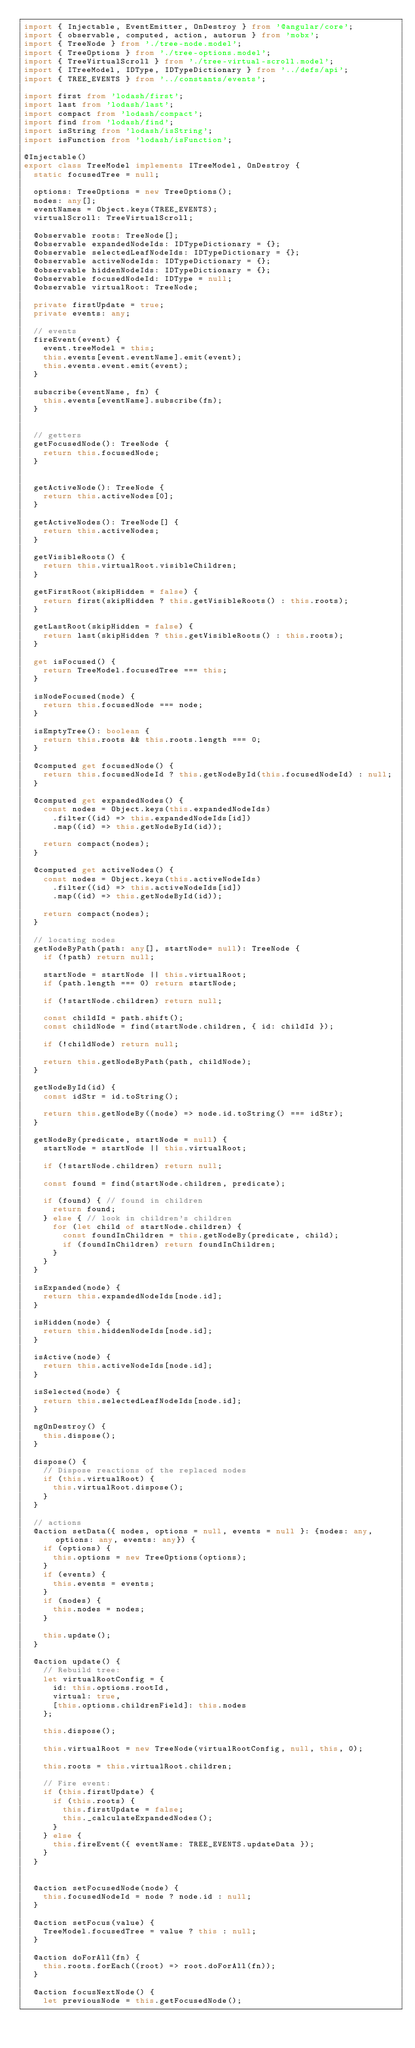<code> <loc_0><loc_0><loc_500><loc_500><_TypeScript_>import { Injectable, EventEmitter, OnDestroy } from '@angular/core';
import { observable, computed, action, autorun } from 'mobx';
import { TreeNode } from './tree-node.model';
import { TreeOptions } from './tree-options.model';
import { TreeVirtualScroll } from './tree-virtual-scroll.model';
import { ITreeModel, IDType, IDTypeDictionary } from '../defs/api';
import { TREE_EVENTS } from '../constants/events';

import first from 'lodash/first';
import last from 'lodash/last';
import compact from 'lodash/compact';
import find from 'lodash/find';
import isString from 'lodash/isString';
import isFunction from 'lodash/isFunction';

@Injectable()
export class TreeModel implements ITreeModel, OnDestroy {
  static focusedTree = null;

  options: TreeOptions = new TreeOptions();
  nodes: any[];
  eventNames = Object.keys(TREE_EVENTS);
  virtualScroll: TreeVirtualScroll;

  @observable roots: TreeNode[];
  @observable expandedNodeIds: IDTypeDictionary = {};
  @observable selectedLeafNodeIds: IDTypeDictionary = {};
  @observable activeNodeIds: IDTypeDictionary = {};
  @observable hiddenNodeIds: IDTypeDictionary = {};
  @observable focusedNodeId: IDType = null;
  @observable virtualRoot: TreeNode;

  private firstUpdate = true;
  private events: any;

  // events
  fireEvent(event) {
    event.treeModel = this;
    this.events[event.eventName].emit(event);
    this.events.event.emit(event);
  }

  subscribe(eventName, fn) {
    this.events[eventName].subscribe(fn);
  }


  // getters
  getFocusedNode(): TreeNode {
    return this.focusedNode;
  }


  getActiveNode(): TreeNode {
    return this.activeNodes[0];
  }

  getActiveNodes(): TreeNode[] {
    return this.activeNodes;
  }

  getVisibleRoots() {
    return this.virtualRoot.visibleChildren;
  }

  getFirstRoot(skipHidden = false) {
    return first(skipHidden ? this.getVisibleRoots() : this.roots);
  }

  getLastRoot(skipHidden = false) {
    return last(skipHidden ? this.getVisibleRoots() : this.roots);
  }

  get isFocused() {
    return TreeModel.focusedTree === this;
  }

  isNodeFocused(node) {
    return this.focusedNode === node;
  }

  isEmptyTree(): boolean {
    return this.roots && this.roots.length === 0;
  }

  @computed get focusedNode() {
    return this.focusedNodeId ? this.getNodeById(this.focusedNodeId) : null;
  }

  @computed get expandedNodes() {
    const nodes = Object.keys(this.expandedNodeIds)
      .filter((id) => this.expandedNodeIds[id])
      .map((id) => this.getNodeById(id));

    return compact(nodes);
  }

  @computed get activeNodes() {
    const nodes = Object.keys(this.activeNodeIds)
      .filter((id) => this.activeNodeIds[id])
      .map((id) => this.getNodeById(id));

    return compact(nodes);
  }

  // locating nodes
  getNodeByPath(path: any[], startNode= null): TreeNode {
    if (!path) return null;

    startNode = startNode || this.virtualRoot;
    if (path.length === 0) return startNode;

    if (!startNode.children) return null;

    const childId = path.shift();
    const childNode = find(startNode.children, { id: childId });

    if (!childNode) return null;

    return this.getNodeByPath(path, childNode);
  }

  getNodeById(id) {
    const idStr = id.toString();

    return this.getNodeBy((node) => node.id.toString() === idStr);
  }

  getNodeBy(predicate, startNode = null) {
    startNode = startNode || this.virtualRoot;

    if (!startNode.children) return null;

    const found = find(startNode.children, predicate);

    if (found) { // found in children
      return found;
    } else { // look in children's children
      for (let child of startNode.children) {
        const foundInChildren = this.getNodeBy(predicate, child);
        if (foundInChildren) return foundInChildren;
      }
    }
  }

  isExpanded(node) {
    return this.expandedNodeIds[node.id];
  }

  isHidden(node) {
    return this.hiddenNodeIds[node.id];
  }

  isActive(node) {
    return this.activeNodeIds[node.id];
  }

  isSelected(node) {
    return this.selectedLeafNodeIds[node.id];
  }

  ngOnDestroy() {
    this.dispose();
  }

  dispose() {
    // Dispose reactions of the replaced nodes
    if (this.virtualRoot) {
      this.virtualRoot.dispose();
    }
  }

  // actions
  @action setData({ nodes, options = null, events = null }: {nodes: any, options: any, events: any}) {
    if (options) {
      this.options = new TreeOptions(options);
    }
    if (events) {
      this.events = events;
    }
    if (nodes) {
      this.nodes = nodes;
    }

    this.update();
  }

  @action update() {
    // Rebuild tree:
    let virtualRootConfig = {
      id: this.options.rootId,
      virtual: true,
      [this.options.childrenField]: this.nodes
    };

    this.dispose();

    this.virtualRoot = new TreeNode(virtualRootConfig, null, this, 0);

    this.roots = this.virtualRoot.children;

    // Fire event:
    if (this.firstUpdate) {
      if (this.roots) {
        this.firstUpdate = false;
        this._calculateExpandedNodes();
      }
    } else {
      this.fireEvent({ eventName: TREE_EVENTS.updateData });
    }
  }


  @action setFocusedNode(node) {
    this.focusedNodeId = node ? node.id : null;
  }

  @action setFocus(value) {
    TreeModel.focusedTree = value ? this : null;
  }

  @action doForAll(fn) {
    this.roots.forEach((root) => root.doForAll(fn));
  }

  @action focusNextNode() {
    let previousNode = this.getFocusedNode();</code> 